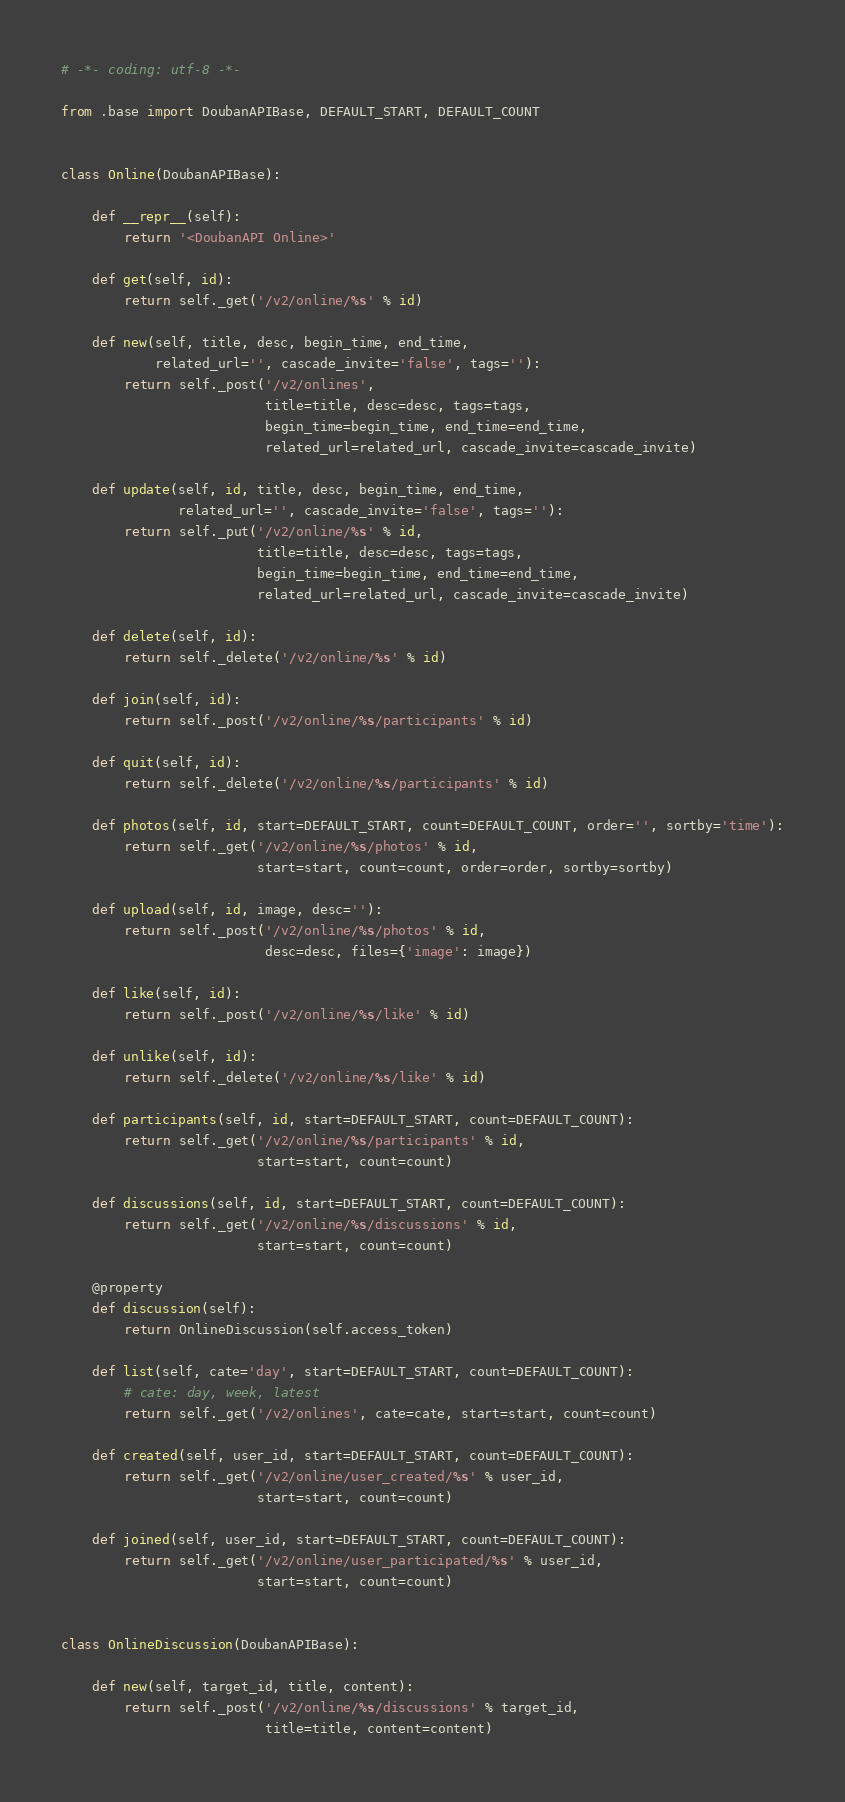Convert code to text. <code><loc_0><loc_0><loc_500><loc_500><_Python_># -*- coding: utf-8 -*-

from .base import DoubanAPIBase, DEFAULT_START, DEFAULT_COUNT


class Online(DoubanAPIBase):

    def __repr__(self):
        return '<DoubanAPI Online>'

    def get(self, id):
        return self._get('/v2/online/%s' % id)

    def new(self, title, desc, begin_time, end_time,
            related_url='', cascade_invite='false', tags=''):
        return self._post('/v2/onlines',
                          title=title, desc=desc, tags=tags,
                          begin_time=begin_time, end_time=end_time,
                          related_url=related_url, cascade_invite=cascade_invite)

    def update(self, id, title, desc, begin_time, end_time,
               related_url='', cascade_invite='false', tags=''):
        return self._put('/v2/online/%s' % id,
                         title=title, desc=desc, tags=tags,
                         begin_time=begin_time, end_time=end_time,
                         related_url=related_url, cascade_invite=cascade_invite)

    def delete(self, id):
        return self._delete('/v2/online/%s' % id)

    def join(self, id):
        return self._post('/v2/online/%s/participants' % id)

    def quit(self, id):
        return self._delete('/v2/online/%s/participants' % id)

    def photos(self, id, start=DEFAULT_START, count=DEFAULT_COUNT, order='', sortby='time'):
        return self._get('/v2/online/%s/photos' % id,
                         start=start, count=count, order=order, sortby=sortby)

    def upload(self, id, image, desc=''):
        return self._post('/v2/online/%s/photos' % id,
                          desc=desc, files={'image': image})

    def like(self, id):
        return self._post('/v2/online/%s/like' % id)

    def unlike(self, id):
        return self._delete('/v2/online/%s/like' % id)

    def participants(self, id, start=DEFAULT_START, count=DEFAULT_COUNT):
        return self._get('/v2/online/%s/participants' % id,
                         start=start, count=count)

    def discussions(self, id, start=DEFAULT_START, count=DEFAULT_COUNT):
        return self._get('/v2/online/%s/discussions' % id,
                         start=start, count=count)

    @property
    def discussion(self):
        return OnlineDiscussion(self.access_token)

    def list(self, cate='day', start=DEFAULT_START, count=DEFAULT_COUNT):
        # cate: day, week, latest
        return self._get('/v2/onlines', cate=cate, start=start, count=count)

    def created(self, user_id, start=DEFAULT_START, count=DEFAULT_COUNT):
        return self._get('/v2/online/user_created/%s' % user_id,
                         start=start, count=count)

    def joined(self, user_id, start=DEFAULT_START, count=DEFAULT_COUNT):
        return self._get('/v2/online/user_participated/%s' % user_id,
                         start=start, count=count)


class OnlineDiscussion(DoubanAPIBase):

    def new(self, target_id, title, content):
        return self._post('/v2/online/%s/discussions' % target_id,
                          title=title, content=content)
</code> 